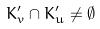Convert formula to latex. <formula><loc_0><loc_0><loc_500><loc_500>K _ { v } ^ { \prime } \cap K _ { u } ^ { \prime } \ne \emptyset</formula> 